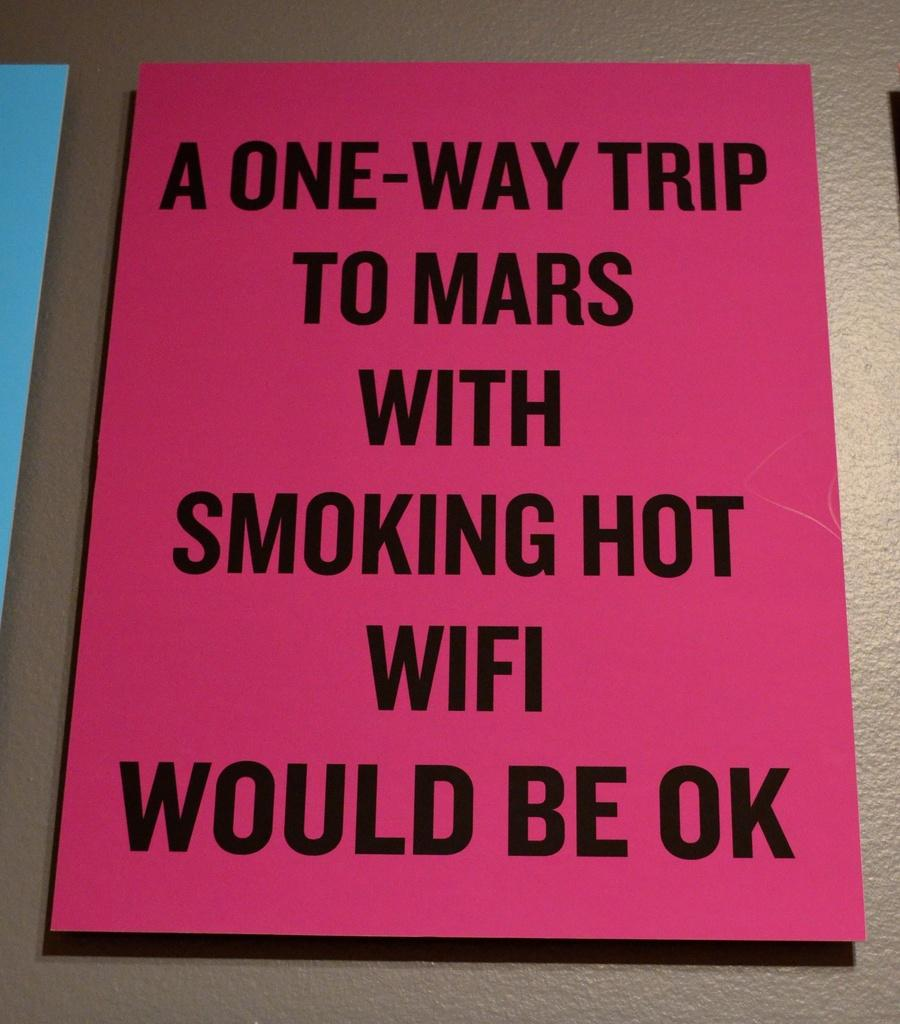<image>
Present a compact description of the photo's key features. A poster for a one way trip to mars being okay as long as it is with smoking hot wifi 